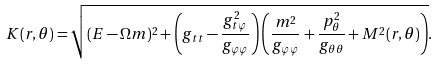Convert formula to latex. <formula><loc_0><loc_0><loc_500><loc_500>K ( r , \theta ) = \sqrt { ( E - \Omega m ) ^ { 2 } + \left ( g _ { t t } - \frac { g _ { t \varphi } ^ { 2 } } { g _ { \varphi \varphi } } \right ) \left ( \frac { m ^ { 2 } } { g _ { \varphi \varphi } } + \frac { p _ { \theta } ^ { 2 } } { g _ { \theta \theta } } + M ^ { 2 } ( r , \theta ) \right ) } .</formula> 